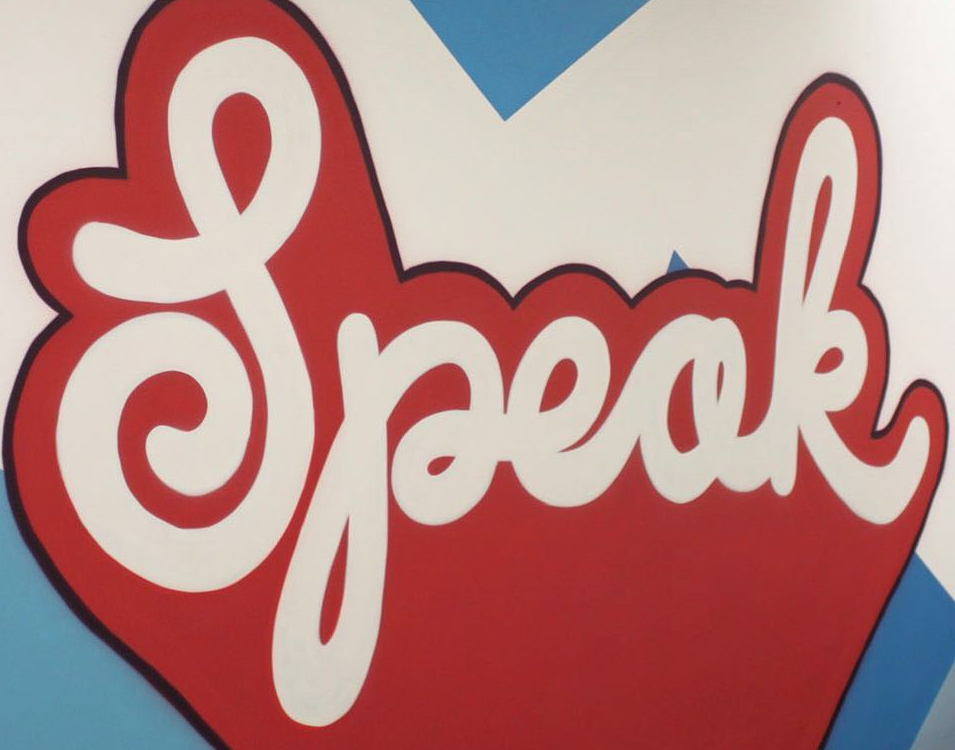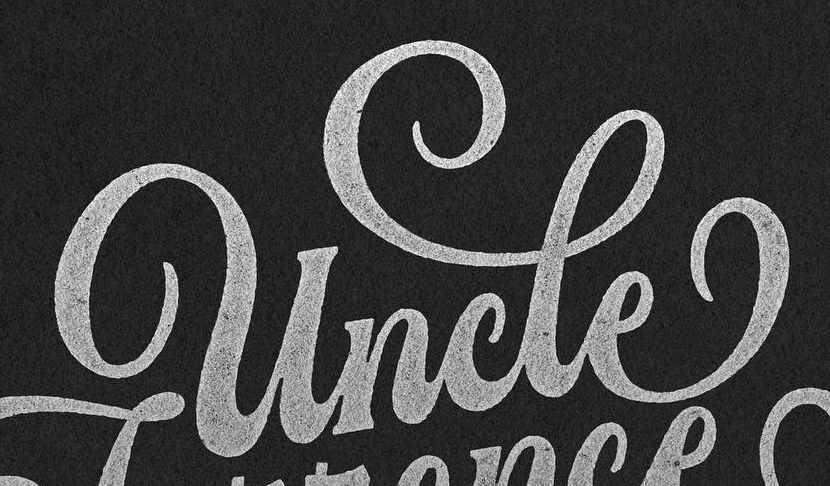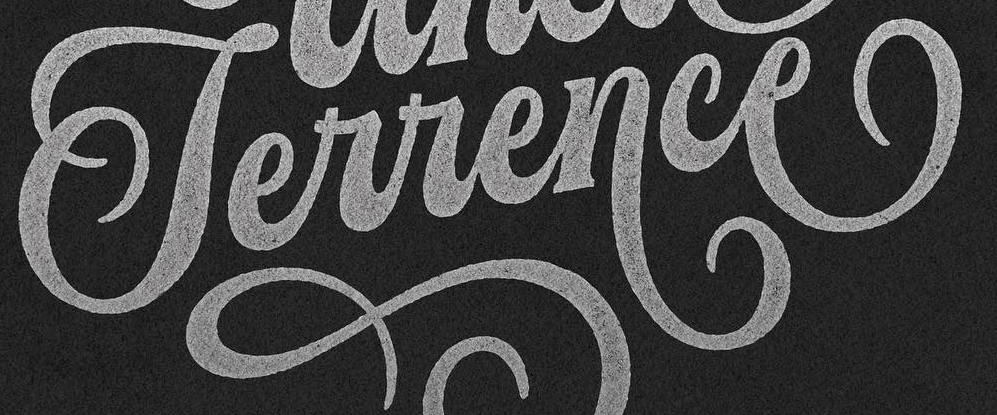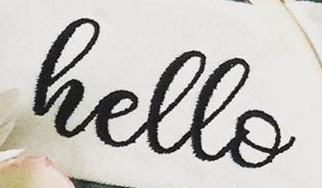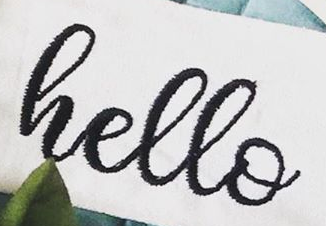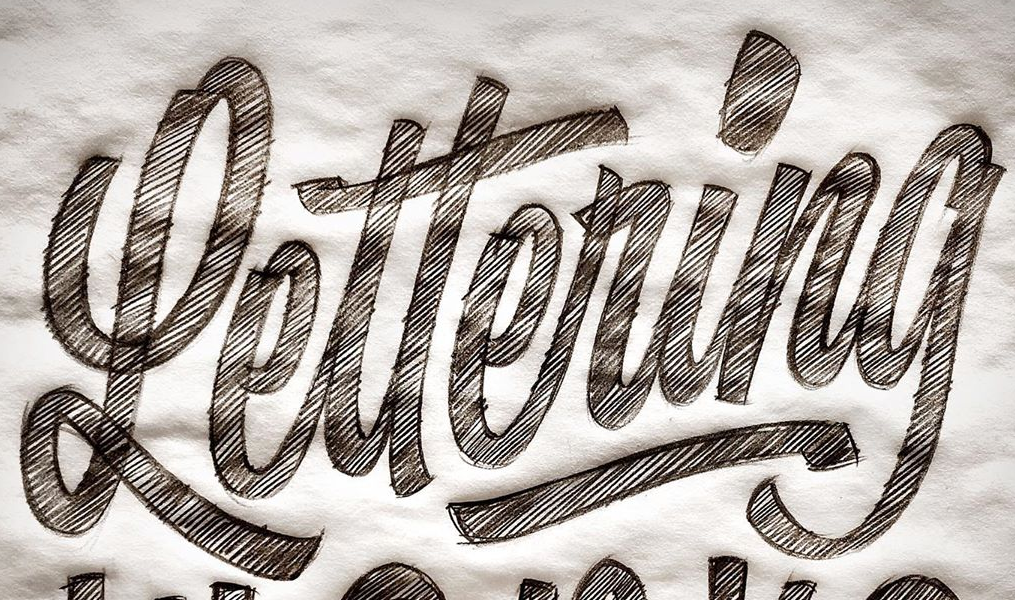Identify the words shown in these images in order, separated by a semicolon. Speak; uncle; Terrence; hello; hello; Lettering 